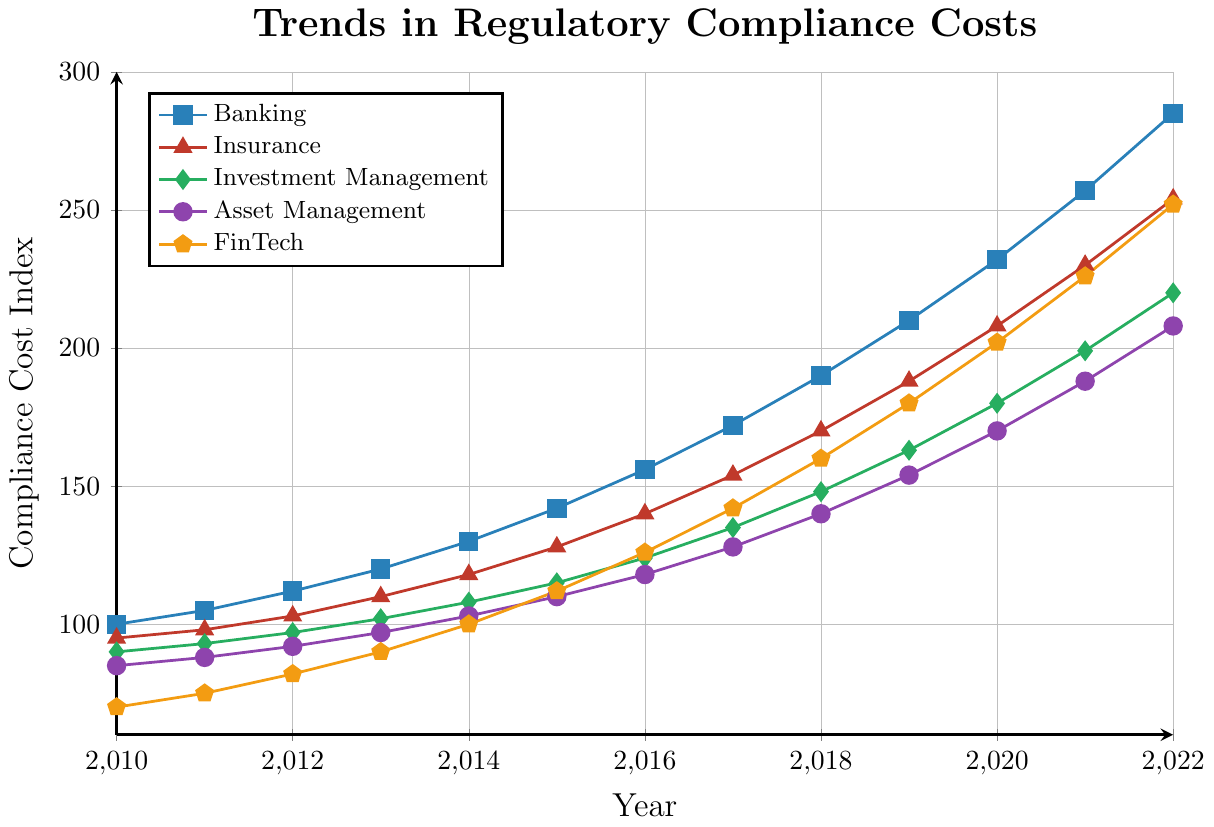What is the trend in regulatory compliance costs for the Banking industry from 2010 to 2022? To interpret the trend, observe the line representing the Banking industry on the chart. Starting at a compliance cost index of 100 in 2010, it consistently increases each year, reaching 285 in 2022.
Answer: Increasing Which industry experienced the highest regulatory compliance cost index in 2022? To determine the highest cost in 2022, look at the endpoint of each line in the chart for 2022. The Banking industry's line ends at 285, which is higher than the other industries.
Answer: Banking What is the difference in compliance costs between the Insurance and Asset Management industries in 2020? Locate the compliance cost indexes for the Insurance and Asset Management industries in 2020. The Insurance industry has an index of 208, and the Asset Management industry has an index of 170. The difference is 208 - 170 = 38.
Answer: 38 What was the average compliance cost index for FinTech in the years 2010, 2012, 2014, and 2016? Find the compliance costs for FinTech in the specified years: 70 (2010), 82 (2012), 100 (2014), and 126 (2016). Sum them up and divide by the number of years: (70 + 82 + 100 + 126) / 4 = 94.5.
Answer: 94.5 Which industry showed the steepest increase in compliance costs between 2018 and 2020? Calculate the increase for each industry between 2018 and 2020:
- Banking: 232 - 190 = 42
- Insurance: 208 - 170 = 38
- Investment Management: 180 - 148 = 32
- Asset Management: 170 - 140 = 30
- FinTech: 202 - 160 = 42
Banking and FinTech both have the highest increase of 42.
Answer: Banking and FinTech How much did the compliance cost for Investment Management increase from 2011 to 2015? Check the compliance costs for Investment Management in 2011 (93) and 2015 (115). The increase is calculated as 115 - 93 = 22.
Answer: 22 What is the compliance cost index for the Asset Management industry in 2013, and how does it compare to that of the Investment Management industry in the same year? In 2013, the Asset Management industry’s index is 97, and the Investment Management industry’s index is 102. Comparing them, Investment Management has a higher index than Asset Management by 5 (102 - 97).
Answer: Asset Management: 97, Investment Management: 102, Difference: 5 Which industry had the lowest compliance cost index in 2015 and what was it? See the values for 2015 and find the lowest: Banking (142), Insurance (128), Investment Management (115), Asset Management (110), and FinTech (112). The lowest is the Asset Management industry at 110.
Answer: Asset Management, 110 What was the compliance cost index trend for FinTech compared to that for Insurance from 2016 to 2022? To compare trends, observe the lines for FinTech and Insurance from 2016 to 2022. Both lines show an increasing trend, but FinTech rises more sharply from 126 to 252 (an increase of 126), compared to Insurance, which goes from 140 to 254 (an increase of 114).
Answer: Both increasing, FinTech more sharply What is the average yearly increase in compliance costs for the Banking industry from 2010 to 2022? First, find the total increase: 285 (2022) - 100 (2010) = 185. Next, calculate the number of years: 2022 - 2010 = 12 years. Finally, divide the total increase by the number of years: 185 / 12 ≈ 15.42.
Answer: 15.42 